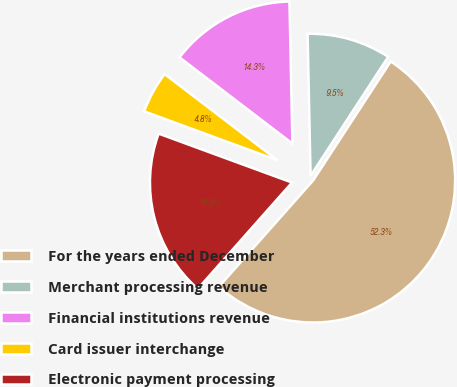<chart> <loc_0><loc_0><loc_500><loc_500><pie_chart><fcel>For the years ended December<fcel>Merchant processing revenue<fcel>Financial institutions revenue<fcel>Card issuer interchange<fcel>Electronic payment processing<nl><fcel>52.35%<fcel>9.53%<fcel>14.29%<fcel>4.78%<fcel>19.05%<nl></chart> 